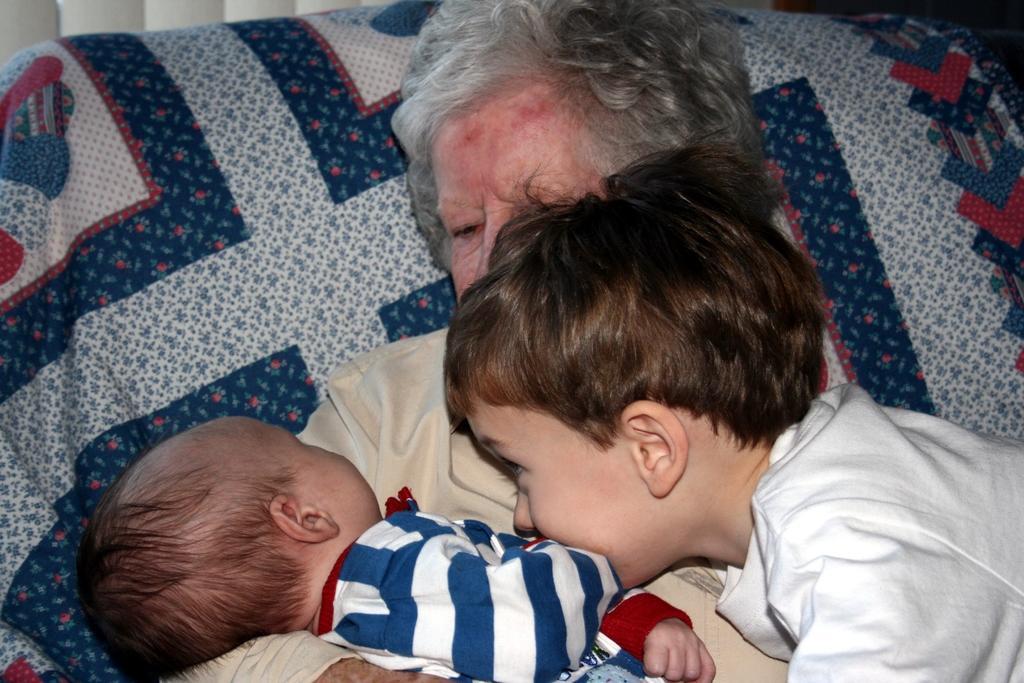In one or two sentences, can you explain what this image depicts? This image consists of persons in the center. In the background there is a pillow which is covered with blue colour bed sheet. 